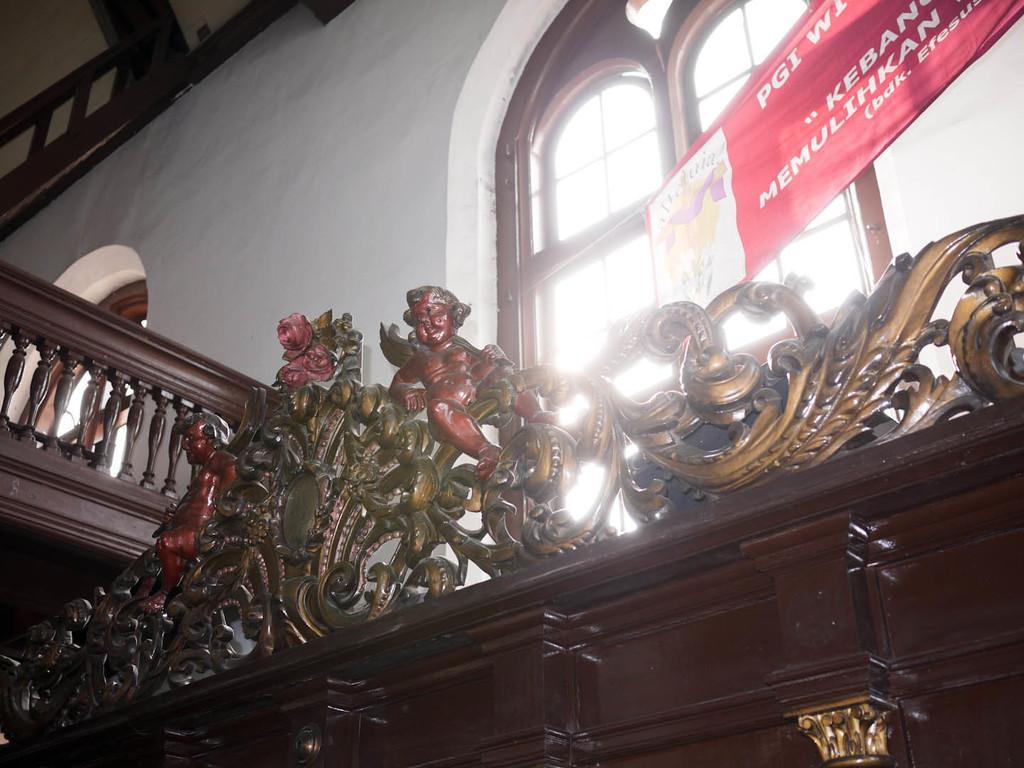What type of furniture is located at the bottom of the image? There are cabinets at the bottom of the image. What is placed on top of the cabinets? There are statues on the cabinets. What can be seen through the window in the image? There is a window in the image, but the view through it is not specified. What architectural feature is present in the image? There are stairs in the image. What decorative element is present in the image? There is a banner in the image. What type of punishment is being depicted by the statues on the cabinets? There is no indication of punishment in the image; the statues are simply decorative elements. How much sugar is present in the banner in the image? There is no sugar mentioned or depicted in the banner in the image. 